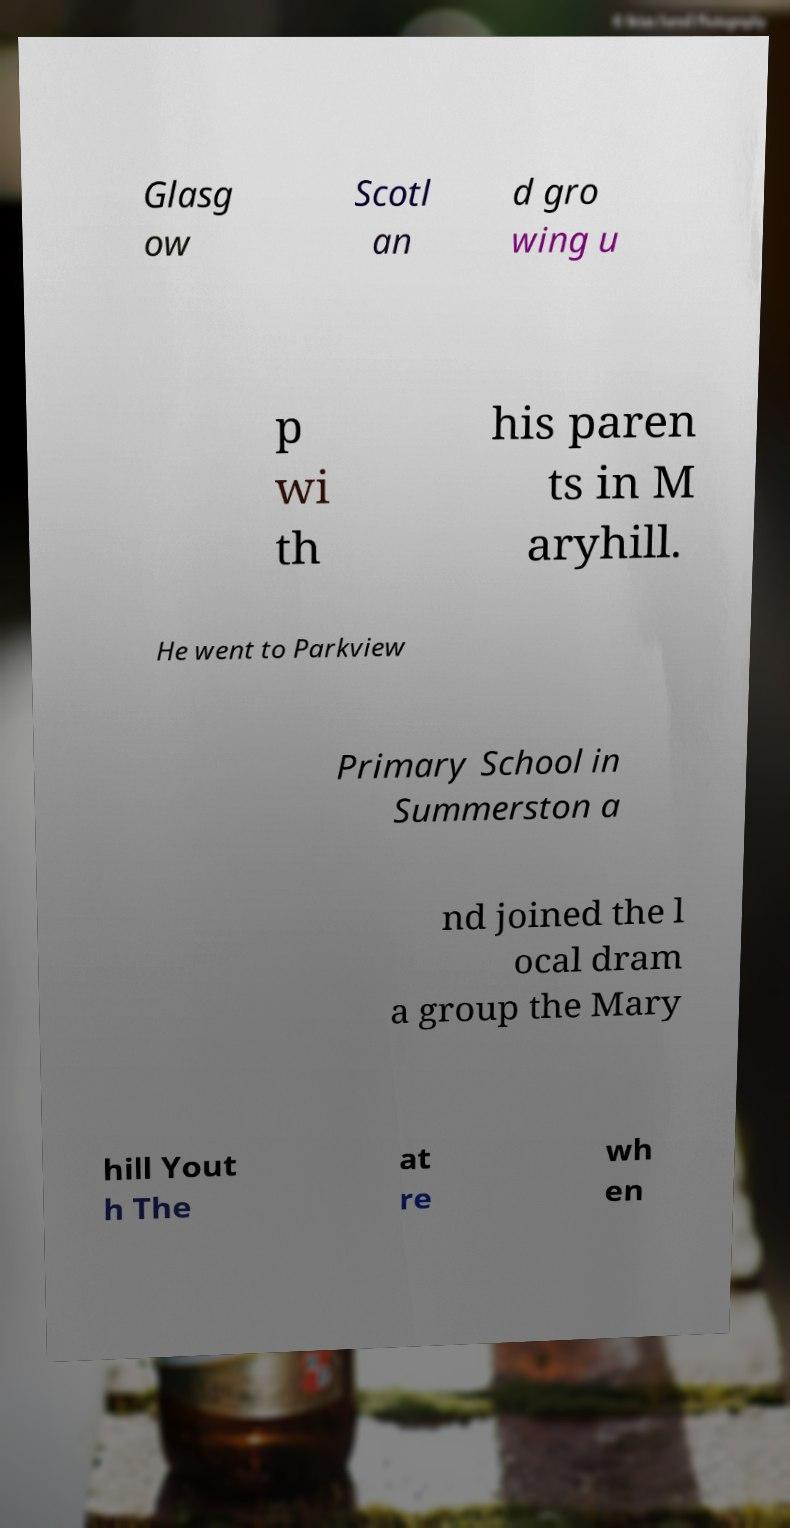Could you assist in decoding the text presented in this image and type it out clearly? Glasg ow Scotl an d gro wing u p wi th his paren ts in M aryhill. He went to Parkview Primary School in Summerston a nd joined the l ocal dram a group the Mary hill Yout h The at re wh en 